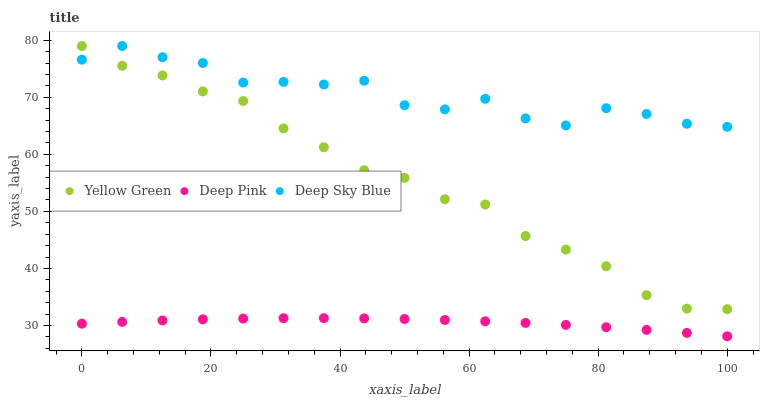Does Deep Pink have the minimum area under the curve?
Answer yes or no. Yes. Does Deep Sky Blue have the maximum area under the curve?
Answer yes or no. Yes. Does Yellow Green have the minimum area under the curve?
Answer yes or no. No. Does Yellow Green have the maximum area under the curve?
Answer yes or no. No. Is Deep Pink the smoothest?
Answer yes or no. Yes. Is Deep Sky Blue the roughest?
Answer yes or no. Yes. Is Yellow Green the smoothest?
Answer yes or no. No. Is Yellow Green the roughest?
Answer yes or no. No. Does Deep Pink have the lowest value?
Answer yes or no. Yes. Does Yellow Green have the lowest value?
Answer yes or no. No. Does Deep Sky Blue have the highest value?
Answer yes or no. Yes. Is Deep Pink less than Deep Sky Blue?
Answer yes or no. Yes. Is Deep Sky Blue greater than Deep Pink?
Answer yes or no. Yes. Does Deep Sky Blue intersect Yellow Green?
Answer yes or no. Yes. Is Deep Sky Blue less than Yellow Green?
Answer yes or no. No. Is Deep Sky Blue greater than Yellow Green?
Answer yes or no. No. Does Deep Pink intersect Deep Sky Blue?
Answer yes or no. No. 